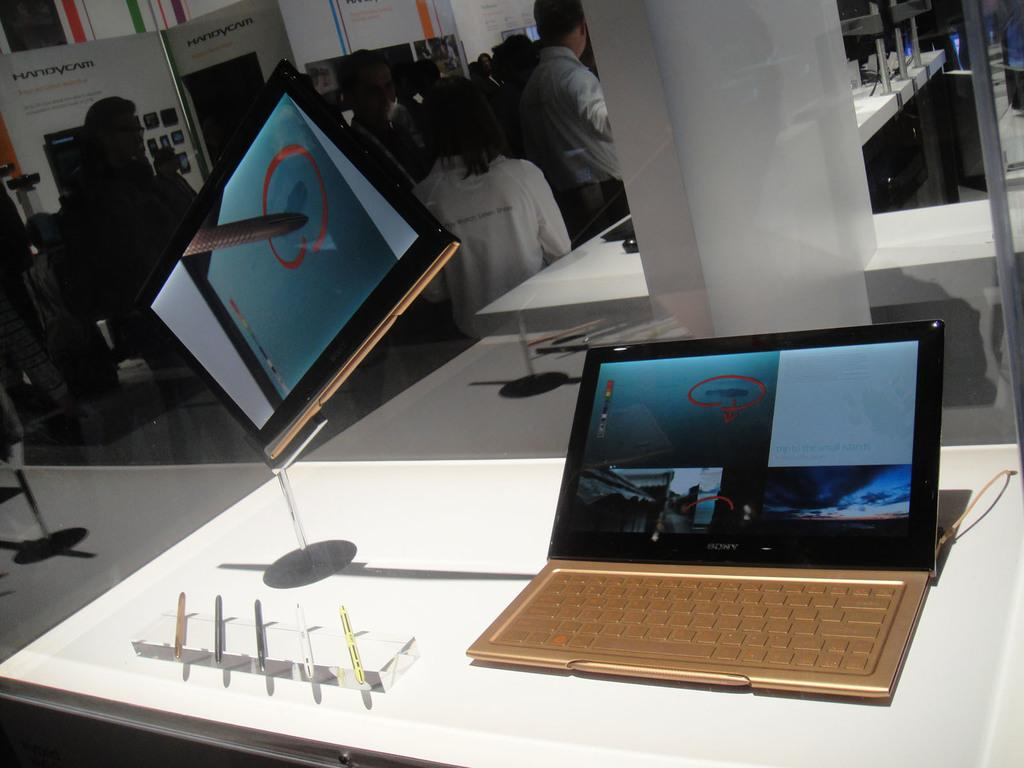What electronic devices are on the table in the image? There is a laptop and a tablet on the table in the image. What stationary items are on the table? There are pens on the table. What can be seen in the background of the image? There is a board and people standing in the background. What type of party is being held in the image? There is no indication of a party in the image; it features a table with electronic devices and stationary items, as well as a background with a board and people standing. 